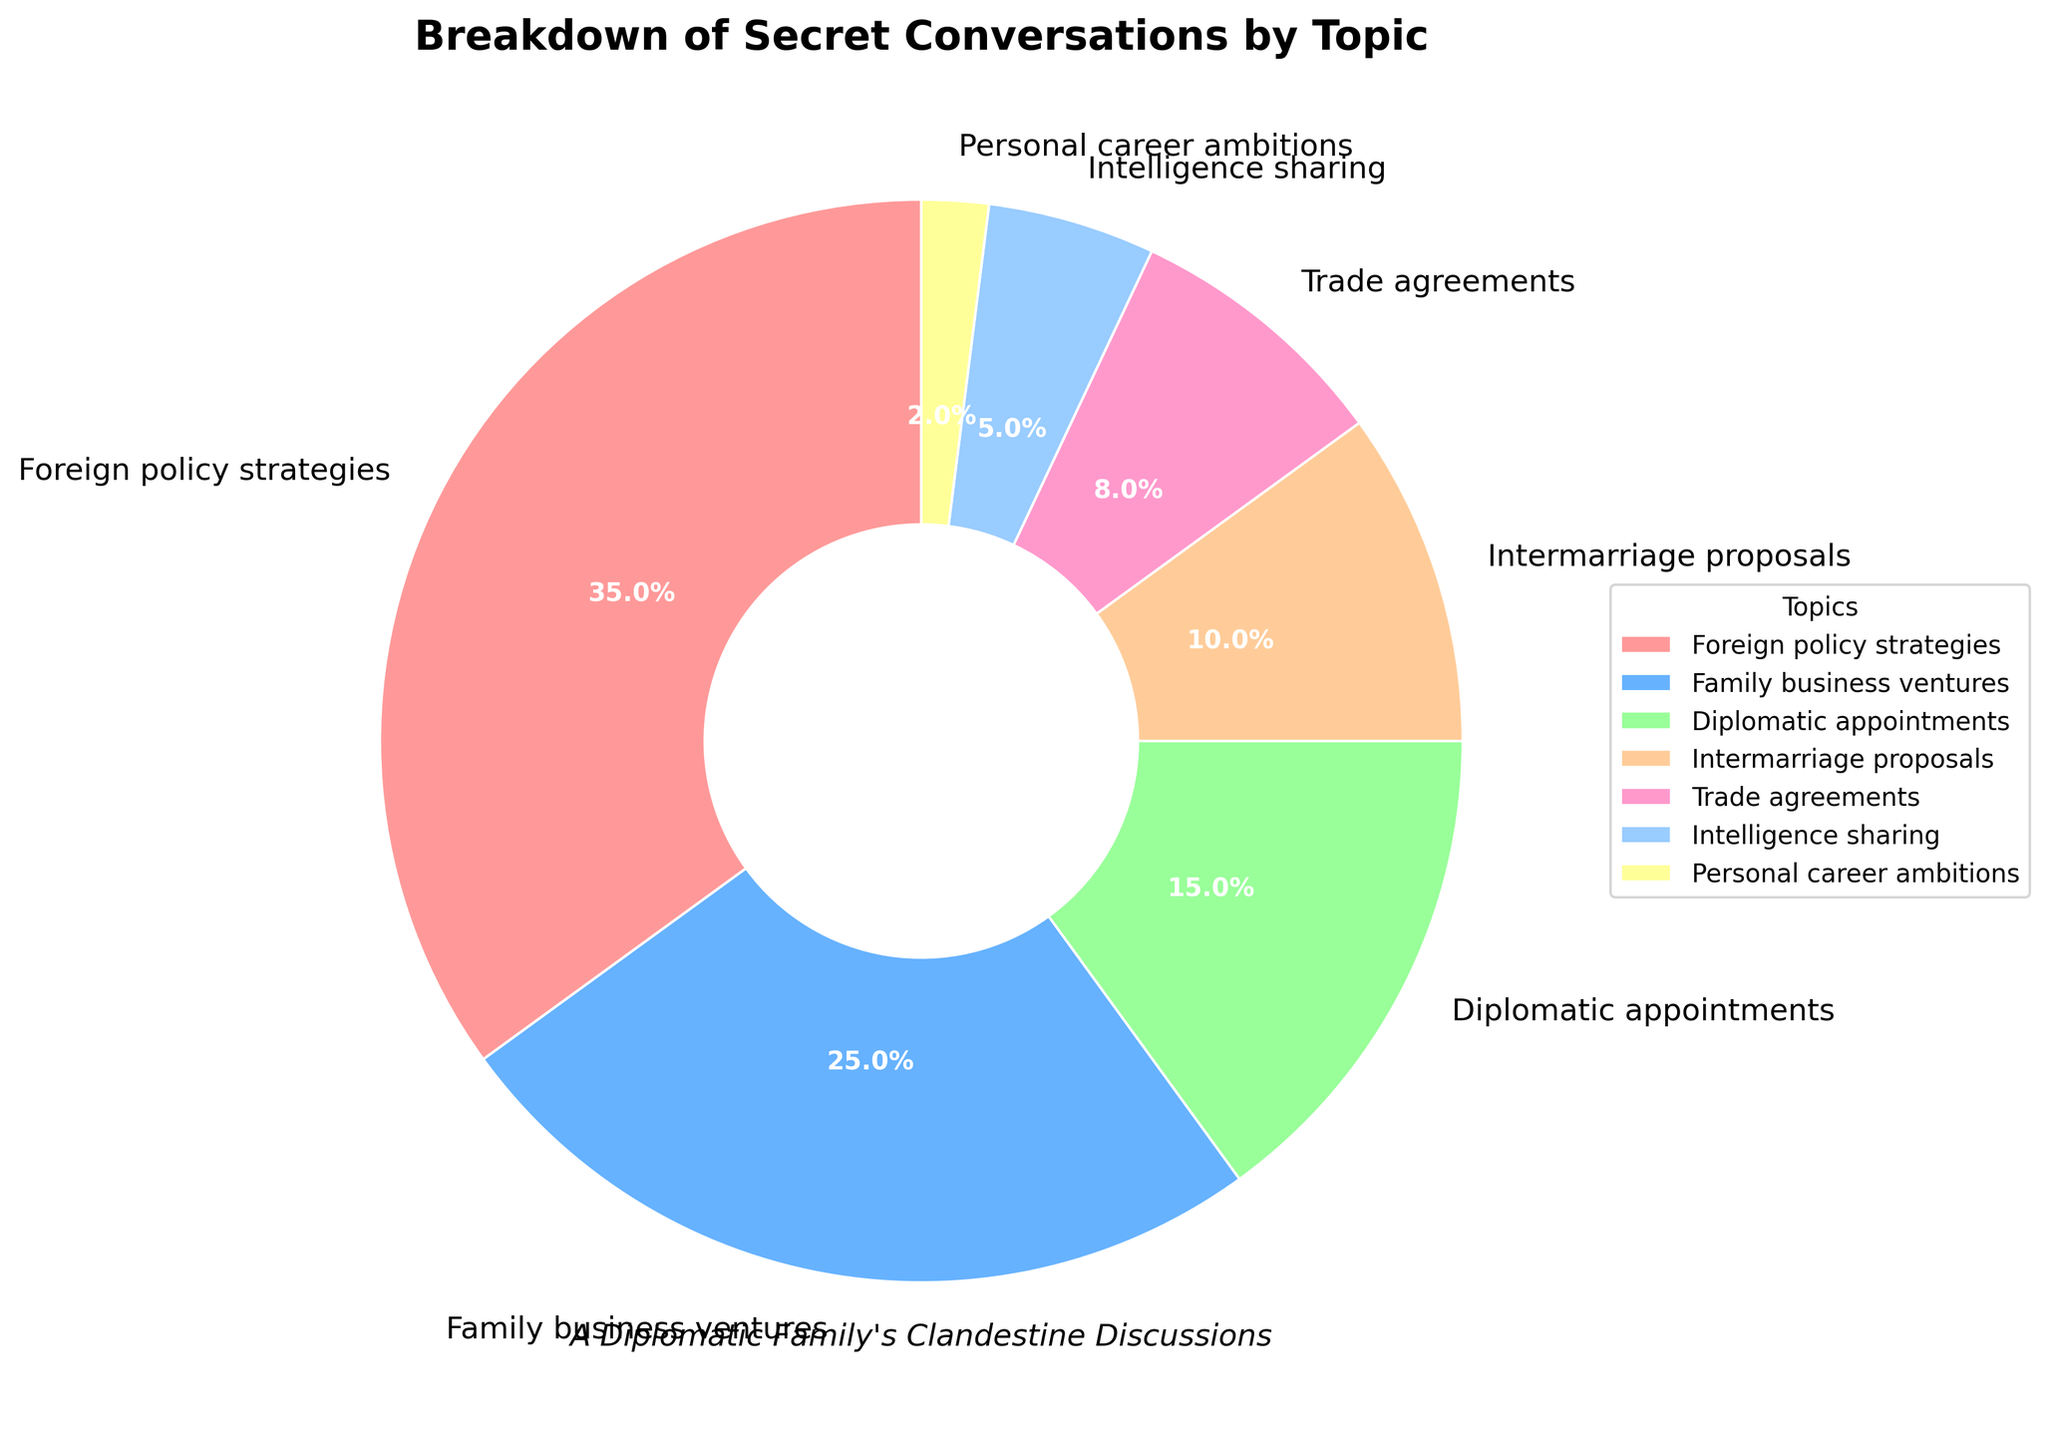what is the combined percentage of conversations on family business ventures and intermarriage proposals? To find the combined percentage, simply add the percentages of the two topics: Family business ventures (25%) and Intermarriage proposals (10%). The calculation is 25% + 10% = 35%.
Answer: 35% which topic has a higher percentage of conversations, trade agreements or intelligence sharing? By looking at the pie chart, we see that Trade agreements have a percentage of 8%, while Intelligence sharing has 5%. 8% > 5%
Answer: Trade agreements what is the percentage difference between conversations on diplomatic appointments and personal career ambitions? First, locate the percentages for each topic: Diplomatic appointments (15%) and Personal career ambitions (2%). Next, subtract the smaller from the larger: 15% - 2% = 13%.
Answer: 13% what color represents the segment for personal career ambitions? By examining the pie chart, we can see that the segment for Personal career ambitions is colored yellow.
Answer: yellow how do the percentages of conversations on trade agreements and intelligence sharing compare to the total percentage? The sum of the percentages for Trade agreements (8%) and Intelligence sharing (5%) is 8% + 5% = 13%.
Answer: 13% which two topics have the closest percentage of conversations? From the pie chart, Diplomatic appointments (15%) and Intermarriage proposals (10%) have the closest percentages, with a difference of 15% - 10% = 5%.
Answer: Diplomatic appointments and Intermarriage proposals if conversations on family business ventures and trade agreements together make up one-quarter of the total, what is the missing percentage? Family business ventures (25%) and Trade agreements (8%) together sum to 25% + 8% = 33%. Given that one-quarter means 25%, the missing percentage can be found by 33% - 25% = 8%.
Answer: 8% what proportion of the conversations pertain to personal career ambitions, expressed as a fraction? The percentage for Personal career ambitions is 2%. To express this as a fraction of 100, we have 2/100, which simplifies to 1/50.
Answer: 1/50 